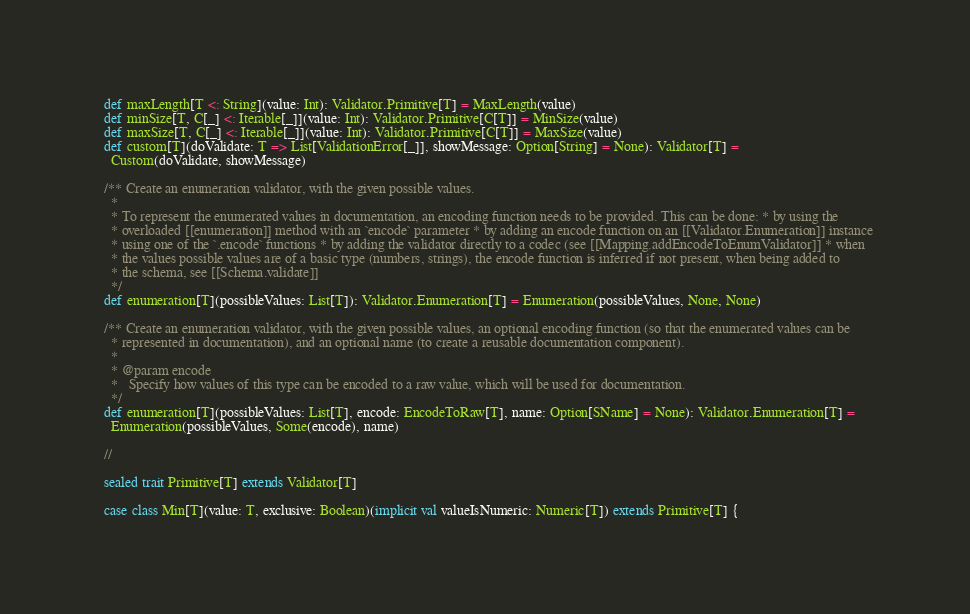Convert code to text. <code><loc_0><loc_0><loc_500><loc_500><_Scala_>  def maxLength[T <: String](value: Int): Validator.Primitive[T] = MaxLength(value)
  def minSize[T, C[_] <: Iterable[_]](value: Int): Validator.Primitive[C[T]] = MinSize(value)
  def maxSize[T, C[_] <: Iterable[_]](value: Int): Validator.Primitive[C[T]] = MaxSize(value)
  def custom[T](doValidate: T => List[ValidationError[_]], showMessage: Option[String] = None): Validator[T] =
    Custom(doValidate, showMessage)

  /** Create an enumeration validator, with the given possible values.
    *
    * To represent the enumerated values in documentation, an encoding function needs to be provided. This can be done: * by using the
    * overloaded [[enumeration]] method with an `encode` parameter * by adding an encode function on an [[Validator.Enumeration]] instance
    * using one of the `.encode` functions * by adding the validator directly to a codec (see [[Mapping.addEncodeToEnumValidator]] * when
    * the values possible values are of a basic type (numbers, strings), the encode function is inferred if not present, when being added to
    * the schema, see [[Schema.validate]]
    */
  def enumeration[T](possibleValues: List[T]): Validator.Enumeration[T] = Enumeration(possibleValues, None, None)

  /** Create an enumeration validator, with the given possible values, an optional encoding function (so that the enumerated values can be
    * represented in documentation), and an optional name (to create a reusable documentation component).
    *
    * @param encode
    *   Specify how values of this type can be encoded to a raw value, which will be used for documentation.
    */
  def enumeration[T](possibleValues: List[T], encode: EncodeToRaw[T], name: Option[SName] = None): Validator.Enumeration[T] =
    Enumeration(possibleValues, Some(encode), name)

  //

  sealed trait Primitive[T] extends Validator[T]

  case class Min[T](value: T, exclusive: Boolean)(implicit val valueIsNumeric: Numeric[T]) extends Primitive[T] {</code> 